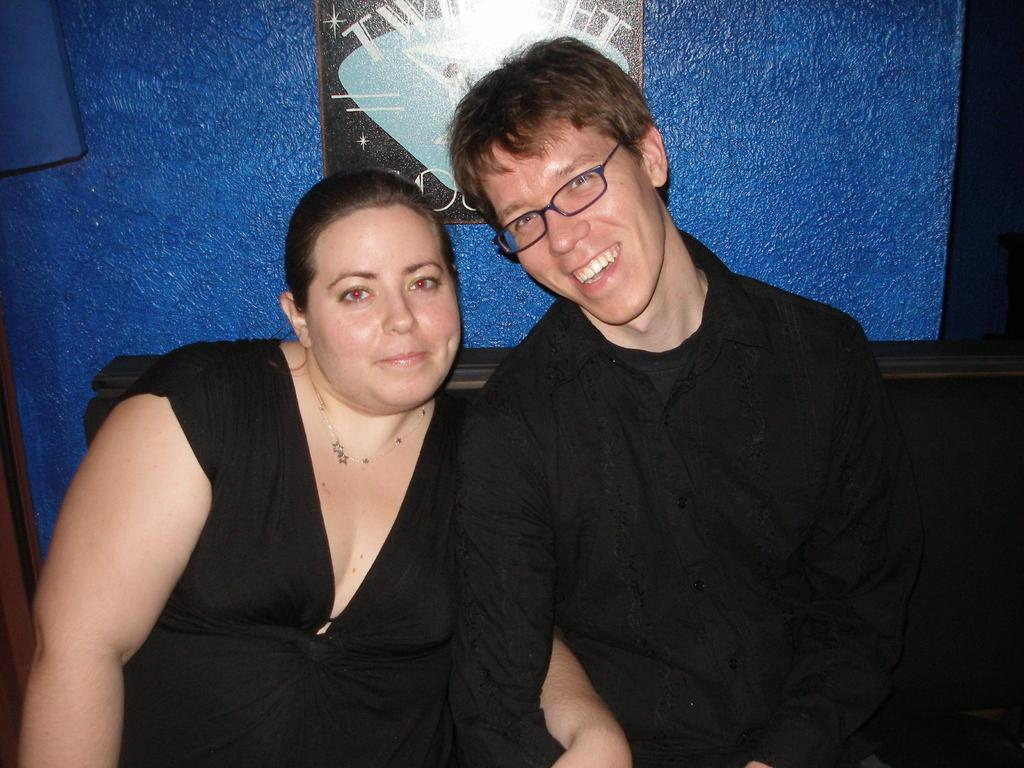How many people are in the image? There are two persons in the image. What are the two persons doing in the image? The two persons are sitting on a couch. What can be seen on the wall in the background of the image? There is a photo frame on the wall in the background of the image. What type of bell can be heard ringing in the image? There is no bell present or ringing in the image. What list is visible on the couch in the image? There is no list visible on the couch or anywhere else in the image. 